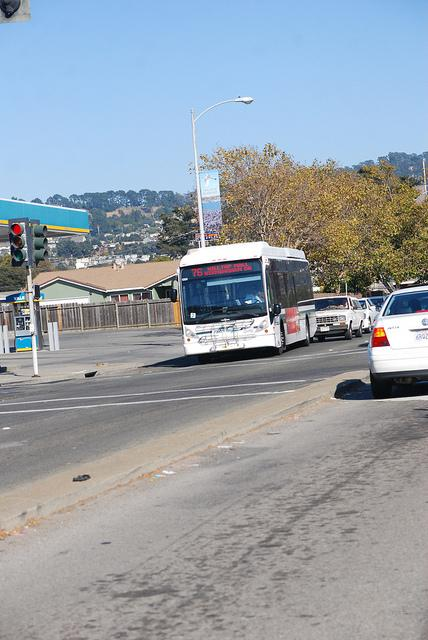Which vehicle is leading the ones on the left side? bus 